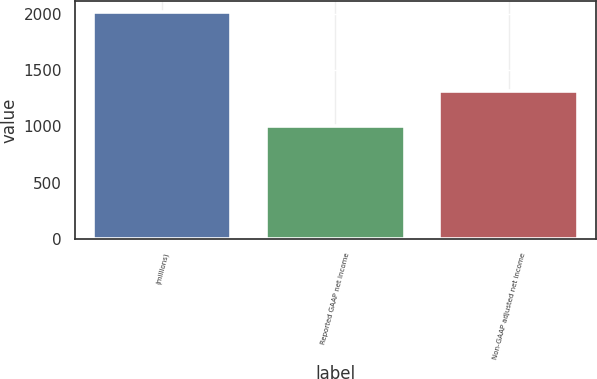Convert chart. <chart><loc_0><loc_0><loc_500><loc_500><bar_chart><fcel>(millions)<fcel>Reported GAAP net income<fcel>Non-GAAP adjusted net income<nl><fcel>2015<fcel>1002.1<fcel>1315.7<nl></chart> 